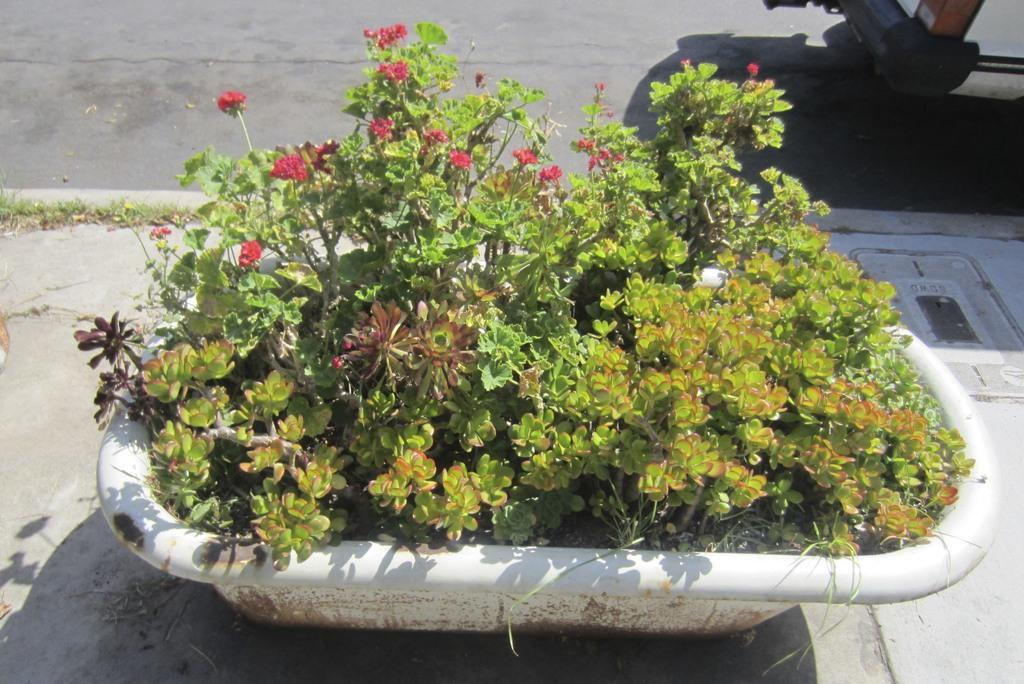What is present in the image? There is a plant in the image. How is the plant contained or displayed? The plant is in a white tub. What additional features does the plant have? The plant has flowers. What color are the flowers? The flowers are red in color. What type of comb is used to style the plant's flowers in the image? There is no comb present in the image, and the flowers are not styled. 